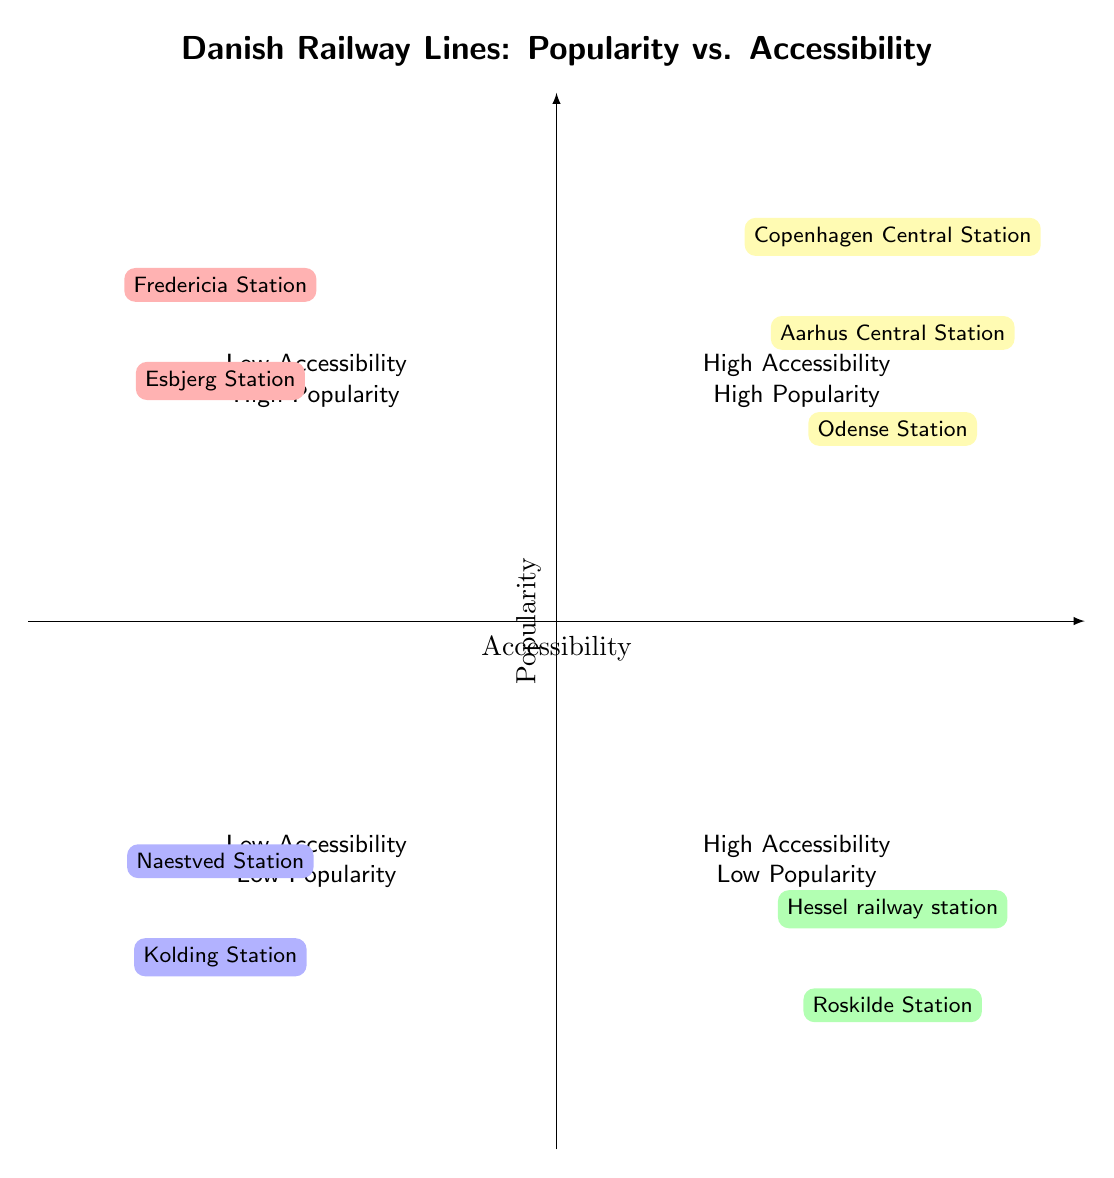What are the railway stations in the High Accessibility - High Popularity quadrant? The High Accessibility - High Popularity quadrant includes three stations. These are listed explicitly in the quadrant as Copenhagen Central Station, Aarhus Central Station, and Odense Station.
Answer: Copenhagen Central Station, Aarhus Central Station, Odense Station How many railway stations have low accessibility and low popularity? The Low Accessibility - Low Popularity quadrant contains two stations. By counting the stations listed in this quadrant, we find that Kolding Station and Naestved Station are present.
Answer: 2 Which station is located in the Low Accessibility - High Popularity quadrant? The Low Accessibility - High Popularity quadrant contains two stations. By identifying the stations listed, we find Fredericia Station and Esbjerg Station are part of this quadrant.
Answer: Fredericia Station, Esbjerg Station Is Hessel railway station located in a quadrant with high popularity? Hessel railway station is located in the High Accessibility - Low Popularity quadrant, which indicates that it is easily accessible but not popular. Therefore, it is not in a quadrant with high popularity.
Answer: No What is the accessibility and popularity of Roskilde Station? Roskilde Station is placed in the High Accessibility - Low Popularity quadrant, showing that it has good accessibility but low popularity among passengers.
Answer: High Accessibility - Low Popularity 